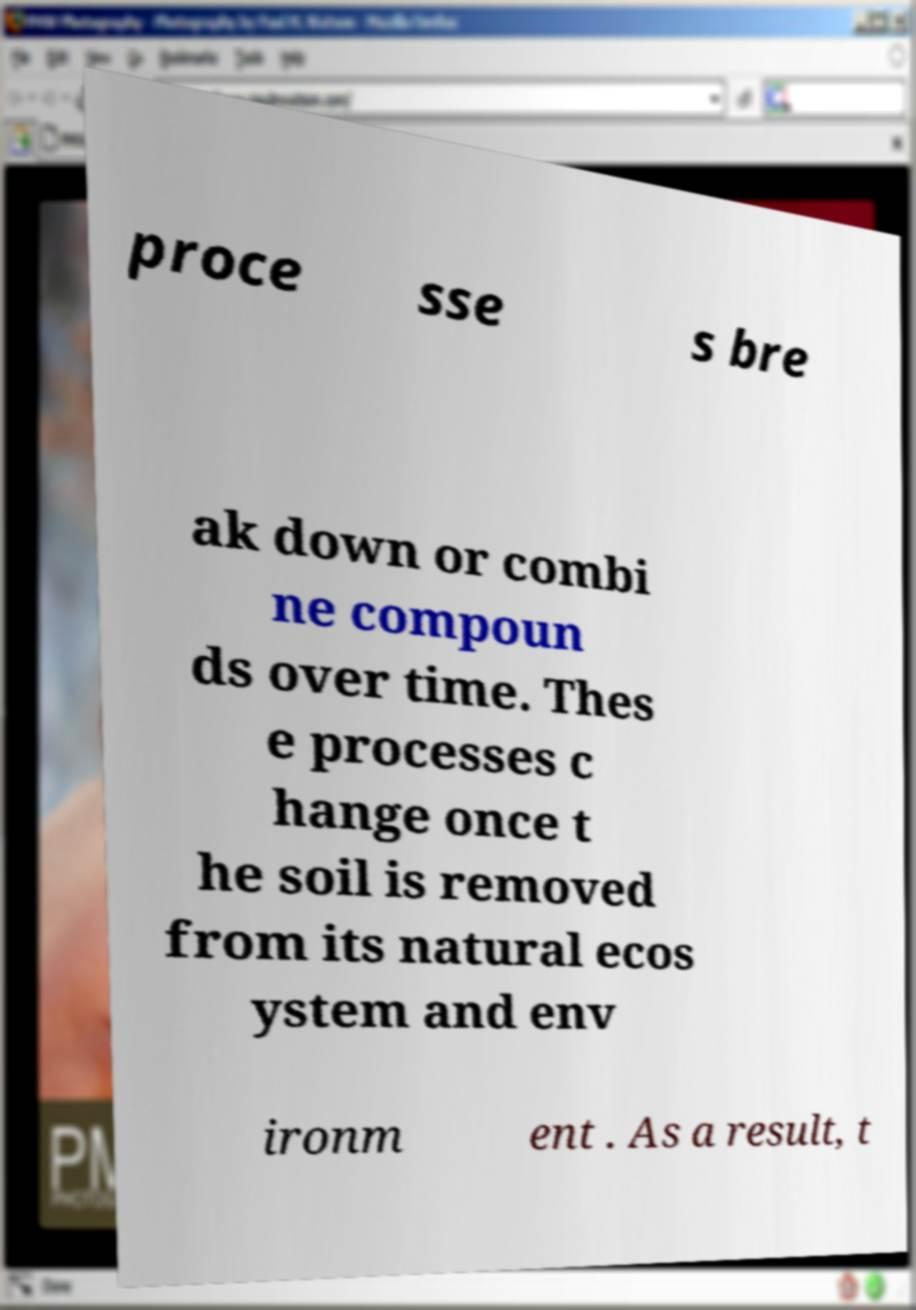I need the written content from this picture converted into text. Can you do that? proce sse s bre ak down or combi ne compoun ds over time. Thes e processes c hange once t he soil is removed from its natural ecos ystem and env ironm ent . As a result, t 